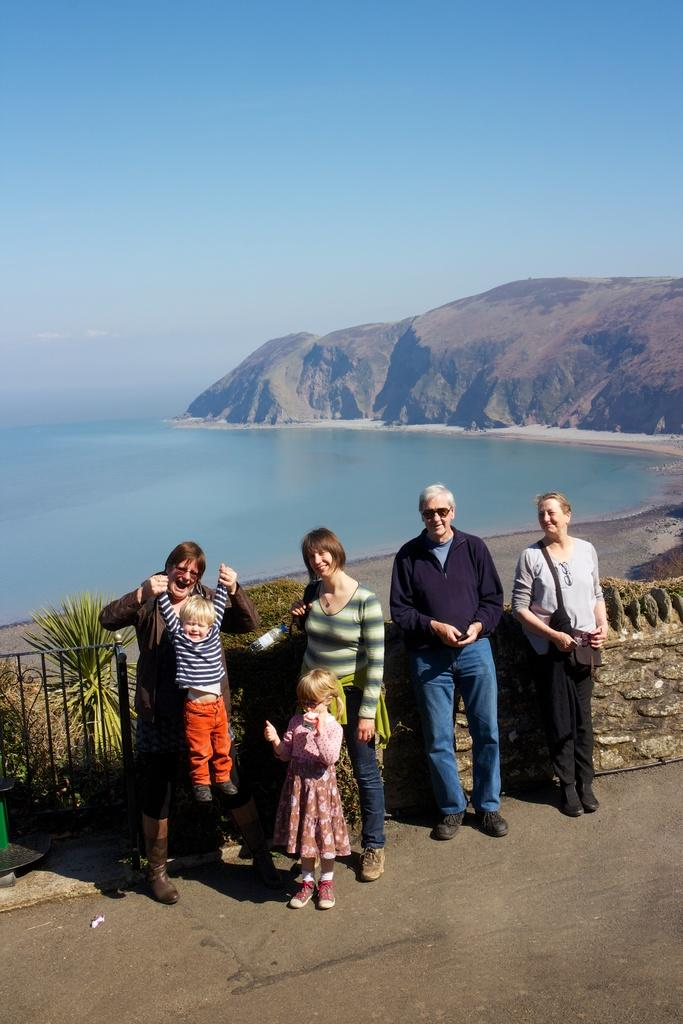What can be seen in the image involving people? There are people standing in the image. What type of barrier is present in the image? There is a fence in the image. What type of vegetation is visible in the image? There are plants in the image. What type of natural landscape can be seen in the image? There are hills visible in the image. What part of the environment is visible in the image? The sky is visible in the image. What type of ship can be seen sailing in the image? There is no ship present in the image. What type of attraction is visible in the image? There is no attraction present in the image. 